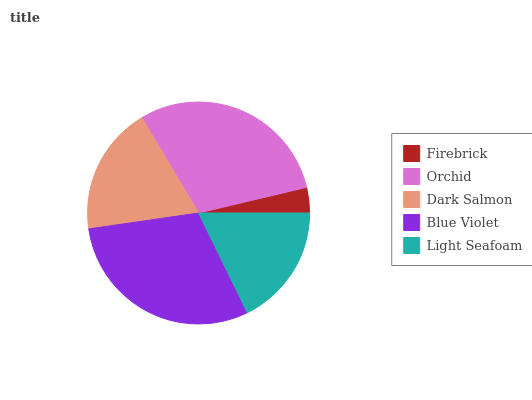Is Firebrick the minimum?
Answer yes or no. Yes. Is Blue Violet the maximum?
Answer yes or no. Yes. Is Orchid the minimum?
Answer yes or no. No. Is Orchid the maximum?
Answer yes or no. No. Is Orchid greater than Firebrick?
Answer yes or no. Yes. Is Firebrick less than Orchid?
Answer yes or no. Yes. Is Firebrick greater than Orchid?
Answer yes or no. No. Is Orchid less than Firebrick?
Answer yes or no. No. Is Dark Salmon the high median?
Answer yes or no. Yes. Is Dark Salmon the low median?
Answer yes or no. Yes. Is Light Seafoam the high median?
Answer yes or no. No. Is Orchid the low median?
Answer yes or no. No. 